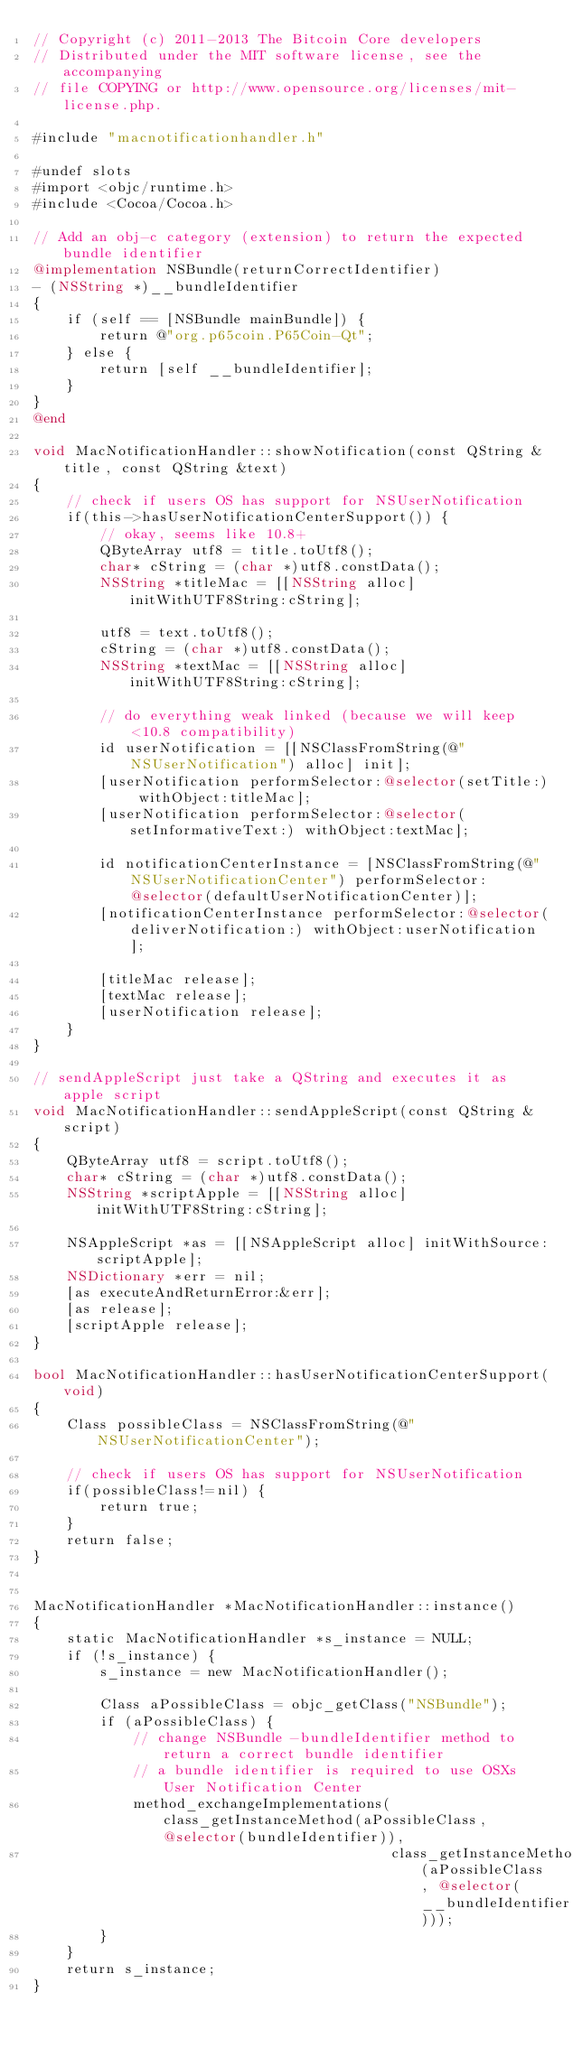Convert code to text. <code><loc_0><loc_0><loc_500><loc_500><_ObjectiveC_>// Copyright (c) 2011-2013 The Bitcoin Core developers
// Distributed under the MIT software license, see the accompanying
// file COPYING or http://www.opensource.org/licenses/mit-license.php.

#include "macnotificationhandler.h"

#undef slots
#import <objc/runtime.h>
#include <Cocoa/Cocoa.h>

// Add an obj-c category (extension) to return the expected bundle identifier
@implementation NSBundle(returnCorrectIdentifier)
- (NSString *)__bundleIdentifier
{
    if (self == [NSBundle mainBundle]) {
        return @"org.p65coin.P65Coin-Qt";
    } else {
        return [self __bundleIdentifier];
    }
}
@end

void MacNotificationHandler::showNotification(const QString &title, const QString &text)
{
    // check if users OS has support for NSUserNotification
    if(this->hasUserNotificationCenterSupport()) {
        // okay, seems like 10.8+
        QByteArray utf8 = title.toUtf8();
        char* cString = (char *)utf8.constData();
        NSString *titleMac = [[NSString alloc] initWithUTF8String:cString];

        utf8 = text.toUtf8();
        cString = (char *)utf8.constData();
        NSString *textMac = [[NSString alloc] initWithUTF8String:cString];

        // do everything weak linked (because we will keep <10.8 compatibility)
        id userNotification = [[NSClassFromString(@"NSUserNotification") alloc] init];
        [userNotification performSelector:@selector(setTitle:) withObject:titleMac];
        [userNotification performSelector:@selector(setInformativeText:) withObject:textMac];

        id notificationCenterInstance = [NSClassFromString(@"NSUserNotificationCenter") performSelector:@selector(defaultUserNotificationCenter)];
        [notificationCenterInstance performSelector:@selector(deliverNotification:) withObject:userNotification];

        [titleMac release];
        [textMac release];
        [userNotification release];
    }
}

// sendAppleScript just take a QString and executes it as apple script
void MacNotificationHandler::sendAppleScript(const QString &script)
{
    QByteArray utf8 = script.toUtf8();
    char* cString = (char *)utf8.constData();
    NSString *scriptApple = [[NSString alloc] initWithUTF8String:cString];

    NSAppleScript *as = [[NSAppleScript alloc] initWithSource:scriptApple];
    NSDictionary *err = nil;
    [as executeAndReturnError:&err];
    [as release];
    [scriptApple release];
}

bool MacNotificationHandler::hasUserNotificationCenterSupport(void)
{
    Class possibleClass = NSClassFromString(@"NSUserNotificationCenter");

    // check if users OS has support for NSUserNotification
    if(possibleClass!=nil) {
        return true;
    }
    return false;
}


MacNotificationHandler *MacNotificationHandler::instance()
{
    static MacNotificationHandler *s_instance = NULL;
    if (!s_instance) {
        s_instance = new MacNotificationHandler();
        
        Class aPossibleClass = objc_getClass("NSBundle");
        if (aPossibleClass) {
            // change NSBundle -bundleIdentifier method to return a correct bundle identifier
            // a bundle identifier is required to use OSXs User Notification Center
            method_exchangeImplementations(class_getInstanceMethod(aPossibleClass, @selector(bundleIdentifier)),
                                           class_getInstanceMethod(aPossibleClass, @selector(__bundleIdentifier)));
        }
    }
    return s_instance;
}
</code> 